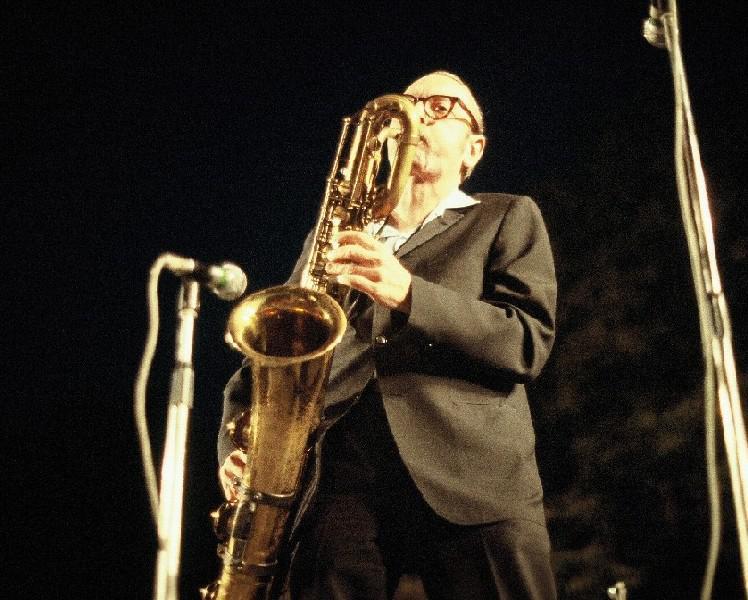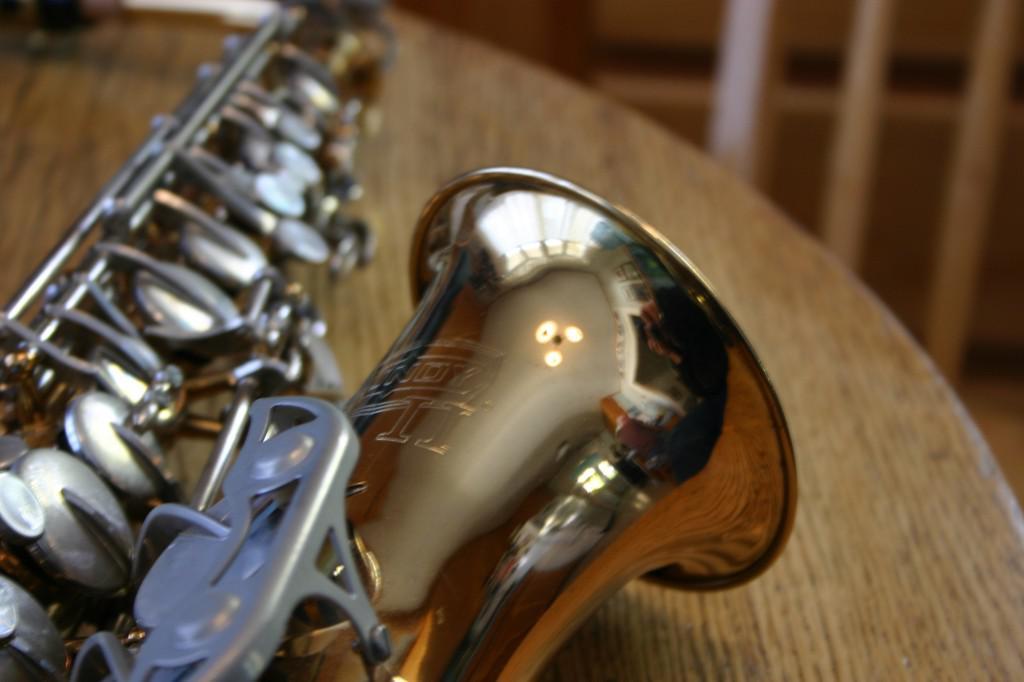The first image is the image on the left, the second image is the image on the right. Evaluate the accuracy of this statement regarding the images: "The left image contains a human touching a saxophone.". Is it true? Answer yes or no. Yes. 